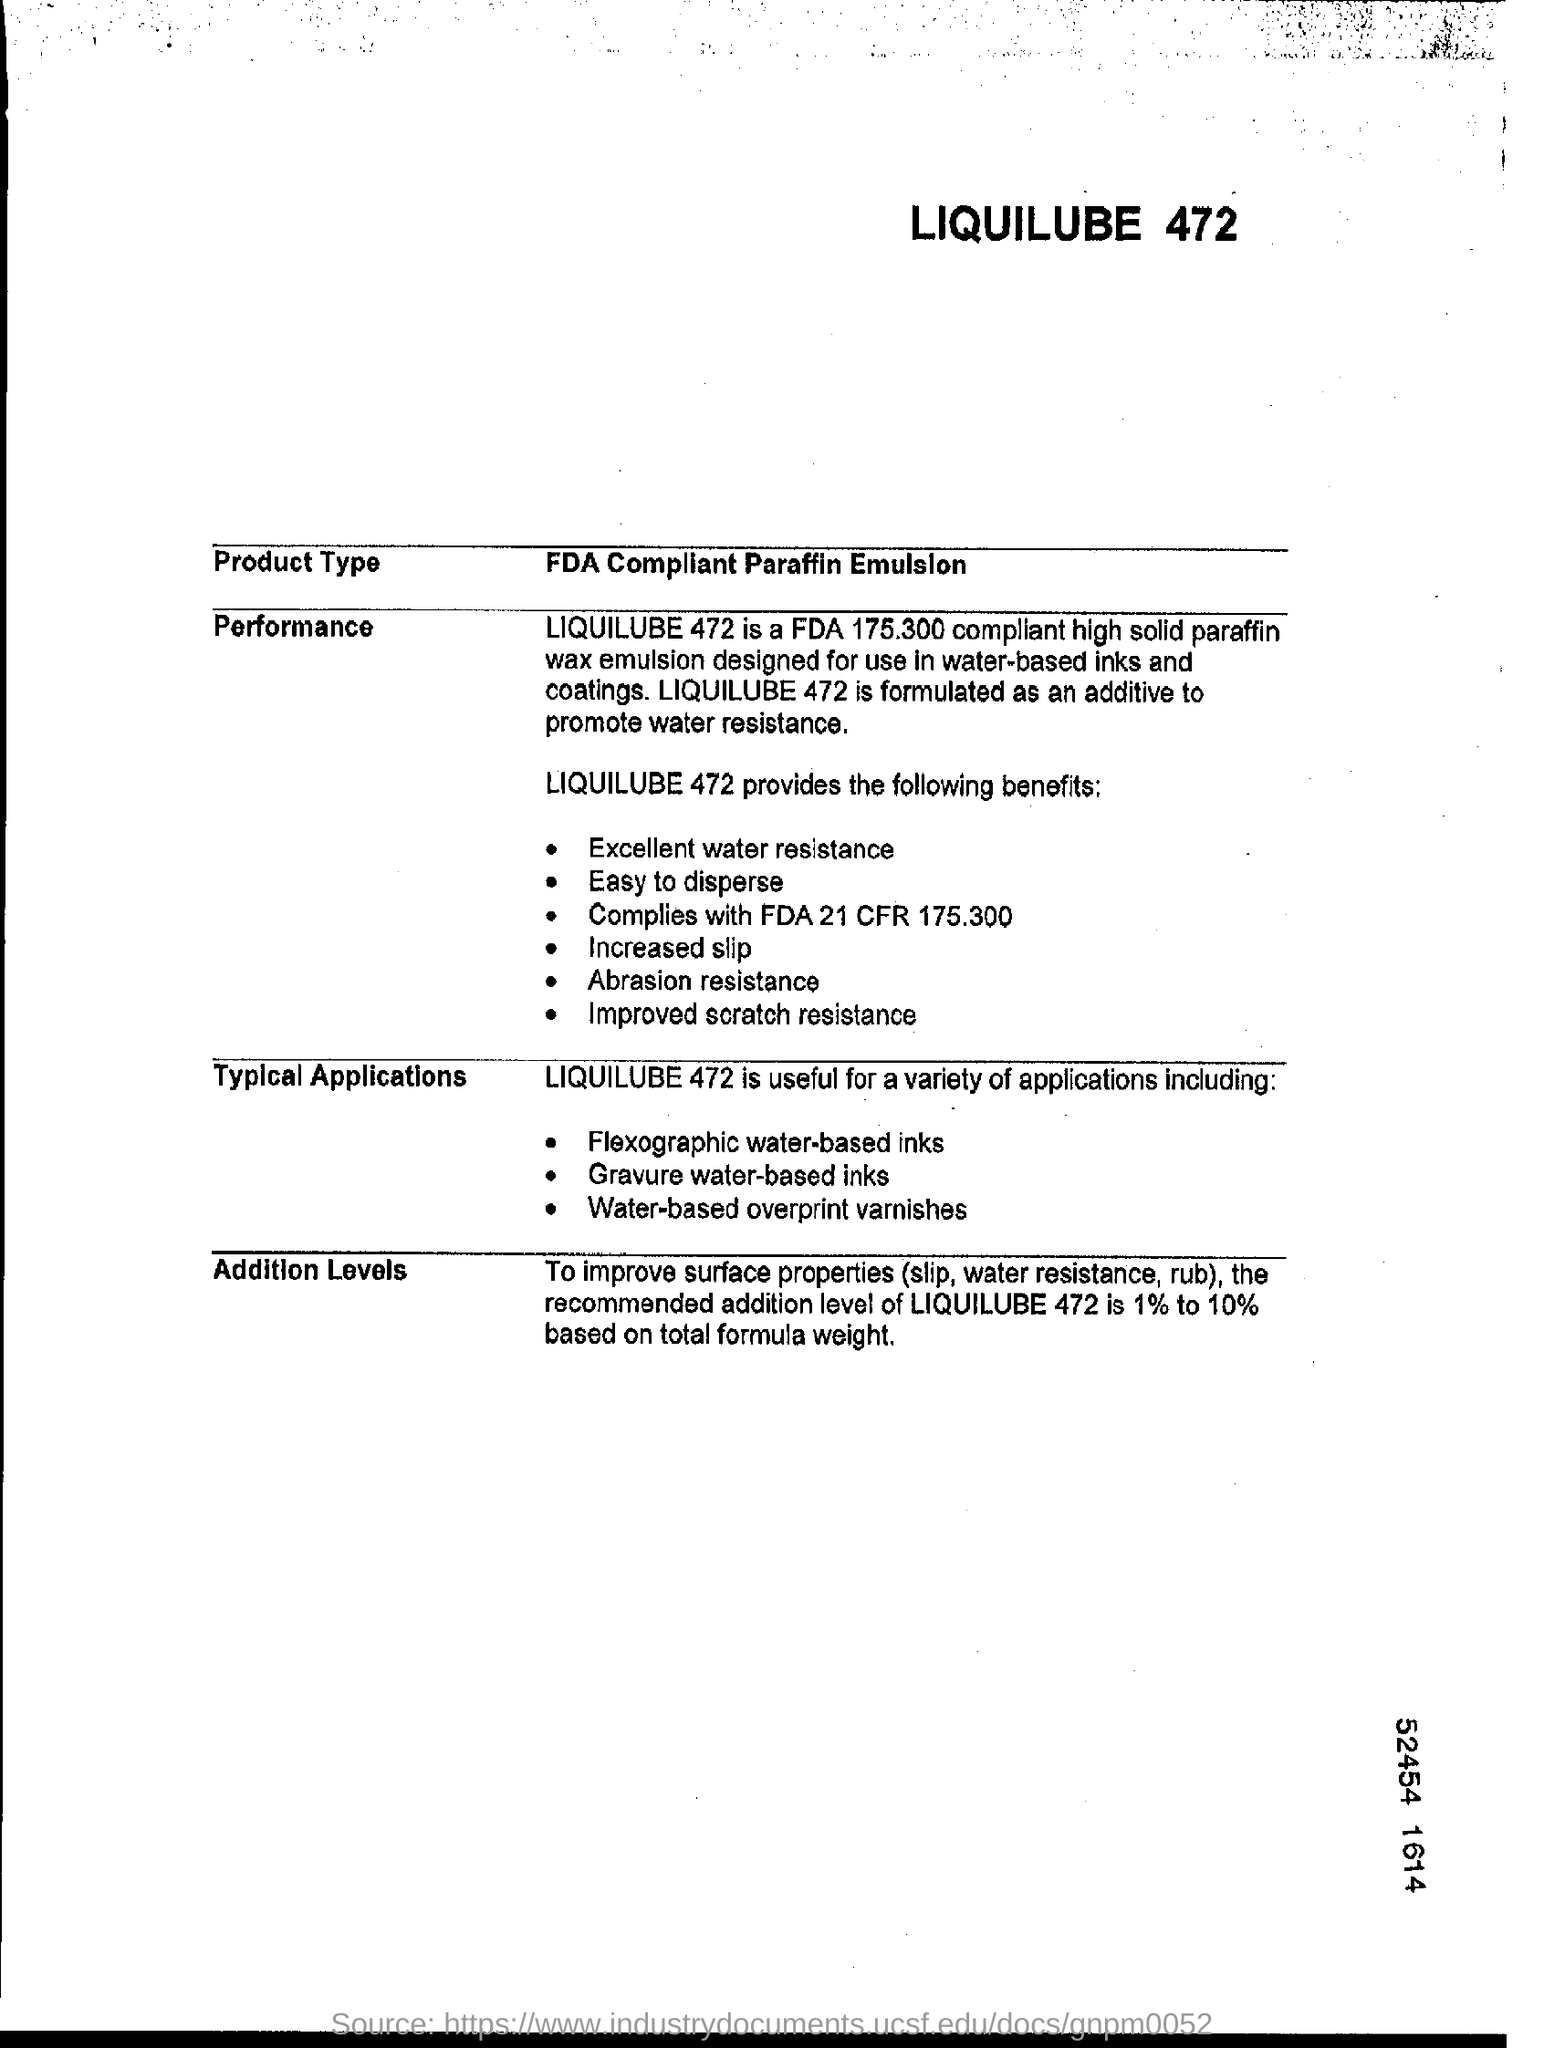List a handful of essential elements in this visual. The recommended addition level of LIQUILUBE 472, when used in a total formula weight range of 1% to 10%, is appropriate for the intended application. 